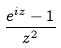<formula> <loc_0><loc_0><loc_500><loc_500>\frac { e ^ { i z } - 1 } { z ^ { 2 } }</formula> 